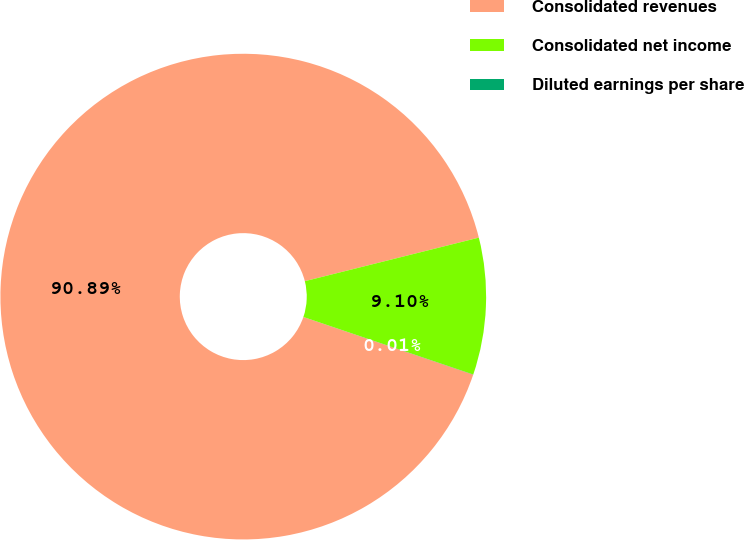Convert chart to OTSL. <chart><loc_0><loc_0><loc_500><loc_500><pie_chart><fcel>Consolidated revenues<fcel>Consolidated net income<fcel>Diluted earnings per share<nl><fcel>90.89%<fcel>9.1%<fcel>0.01%<nl></chart> 